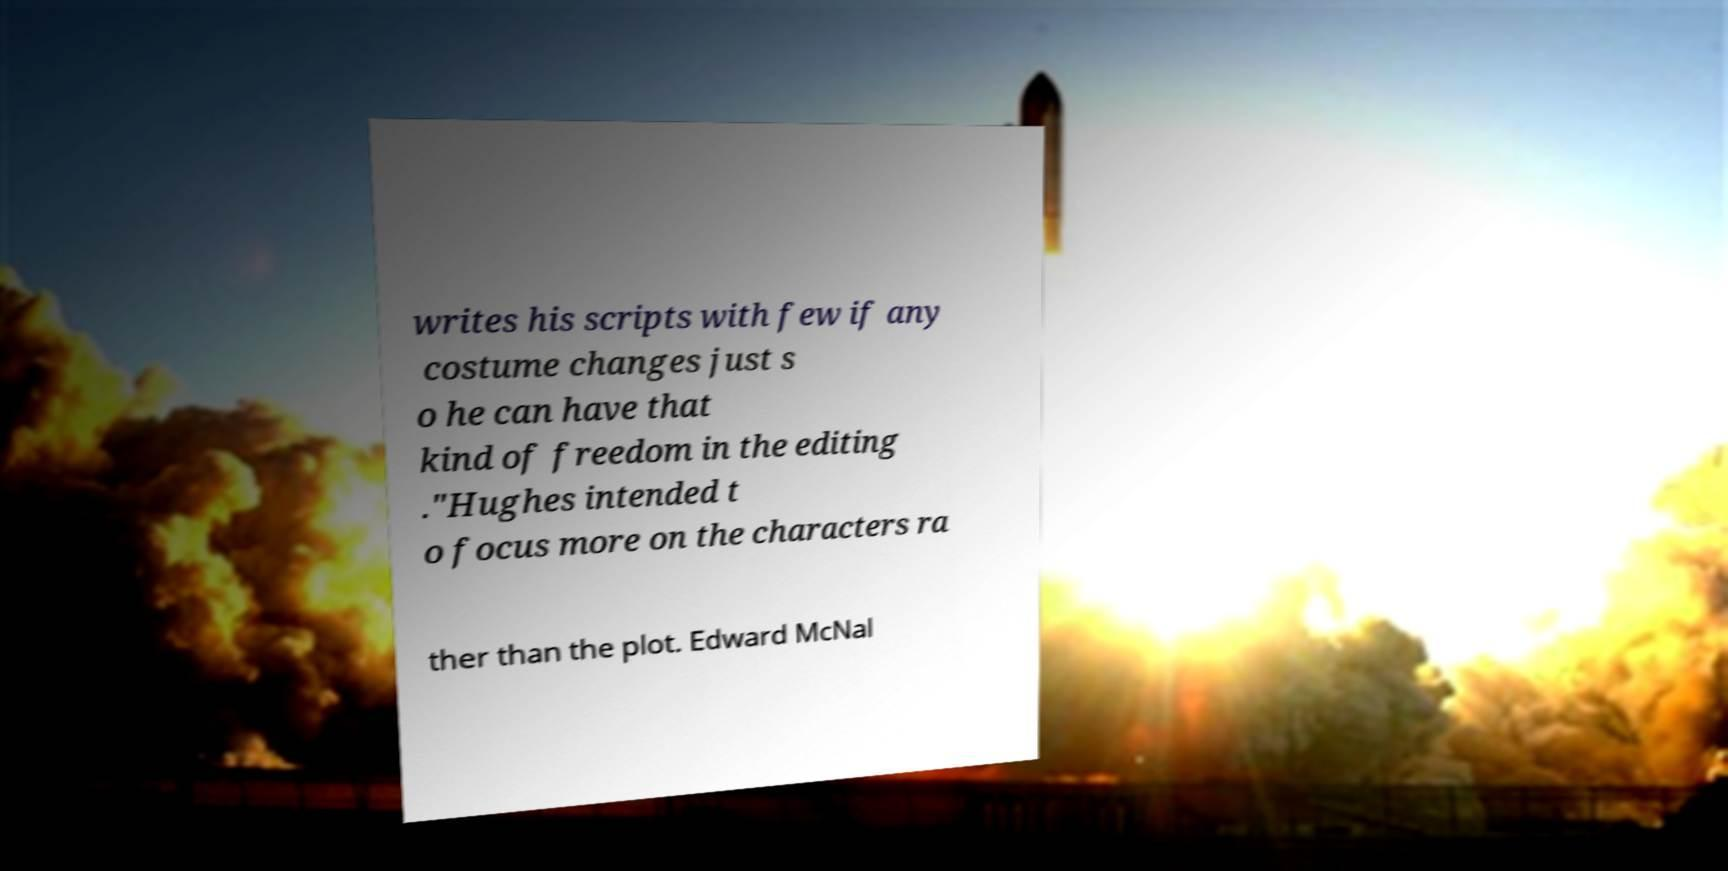For documentation purposes, I need the text within this image transcribed. Could you provide that? writes his scripts with few if any costume changes just s o he can have that kind of freedom in the editing ."Hughes intended t o focus more on the characters ra ther than the plot. Edward McNal 